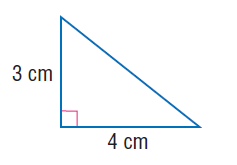Answer the mathemtical geometry problem and directly provide the correct option letter.
Question: Use the Pythagorean Theorem to find the length of the hypotenuse of the right triangle.
Choices: A: \sqrt { 7 } B: 3 C: 4 D: 5 D 